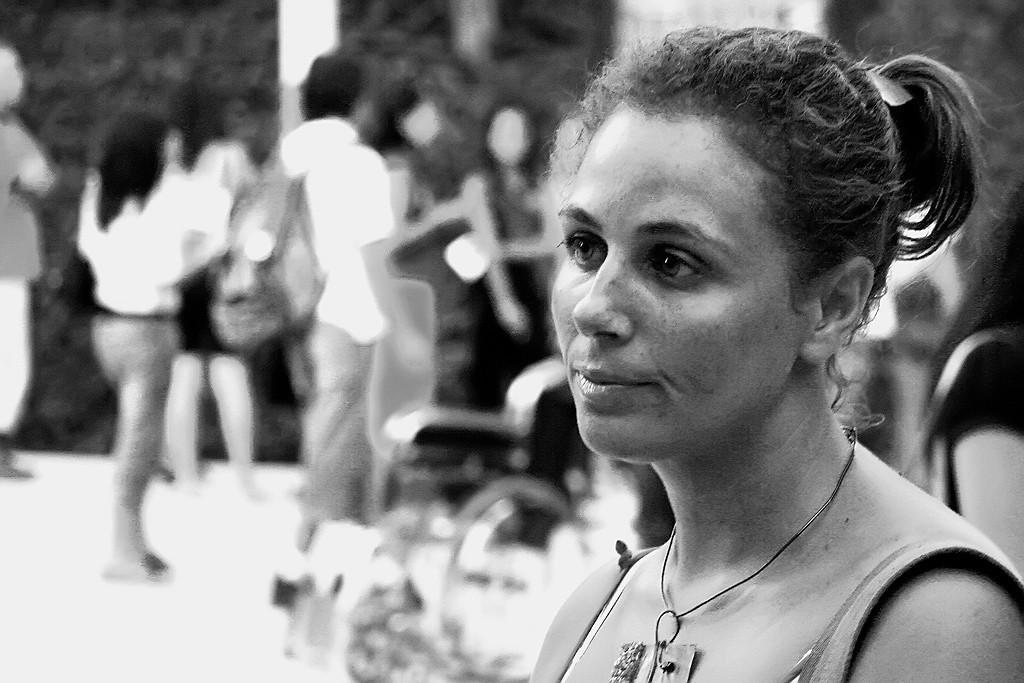Please provide a concise description of this image. In this image I can see a person and I can see blurred background, and the image is in black and white. 